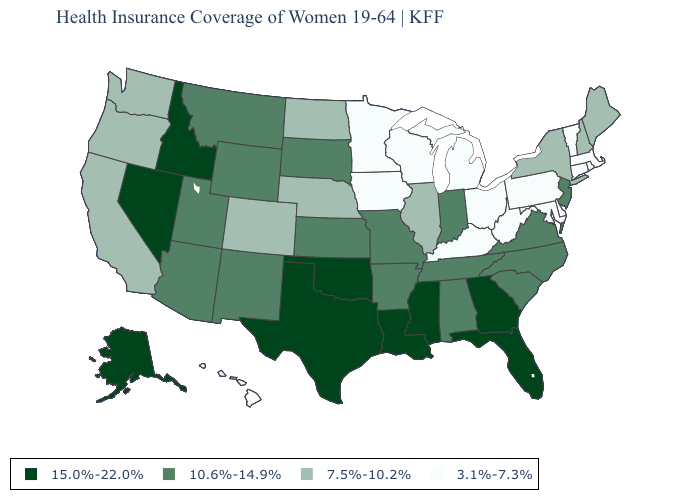Is the legend a continuous bar?
Write a very short answer. No. Which states hav the highest value in the Northeast?
Be succinct. New Jersey. What is the highest value in states that border Utah?
Quick response, please. 15.0%-22.0%. What is the value of West Virginia?
Write a very short answer. 3.1%-7.3%. Does South Dakota have the highest value in the MidWest?
Write a very short answer. Yes. Does South Carolina have a higher value than Arizona?
Be succinct. No. Among the states that border Arizona , which have the lowest value?
Quick response, please. California, Colorado. What is the value of Arkansas?
Keep it brief. 10.6%-14.9%. Does Missouri have the highest value in the USA?
Short answer required. No. Does Maine have a lower value than Kentucky?
Write a very short answer. No. What is the value of New Hampshire?
Write a very short answer. 7.5%-10.2%. Name the states that have a value in the range 3.1%-7.3%?
Be succinct. Connecticut, Delaware, Hawaii, Iowa, Kentucky, Maryland, Massachusetts, Michigan, Minnesota, Ohio, Pennsylvania, Rhode Island, Vermont, West Virginia, Wisconsin. Does the first symbol in the legend represent the smallest category?
Concise answer only. No. What is the highest value in the USA?
Quick response, please. 15.0%-22.0%. Among the states that border Wyoming , which have the highest value?
Be succinct. Idaho. 